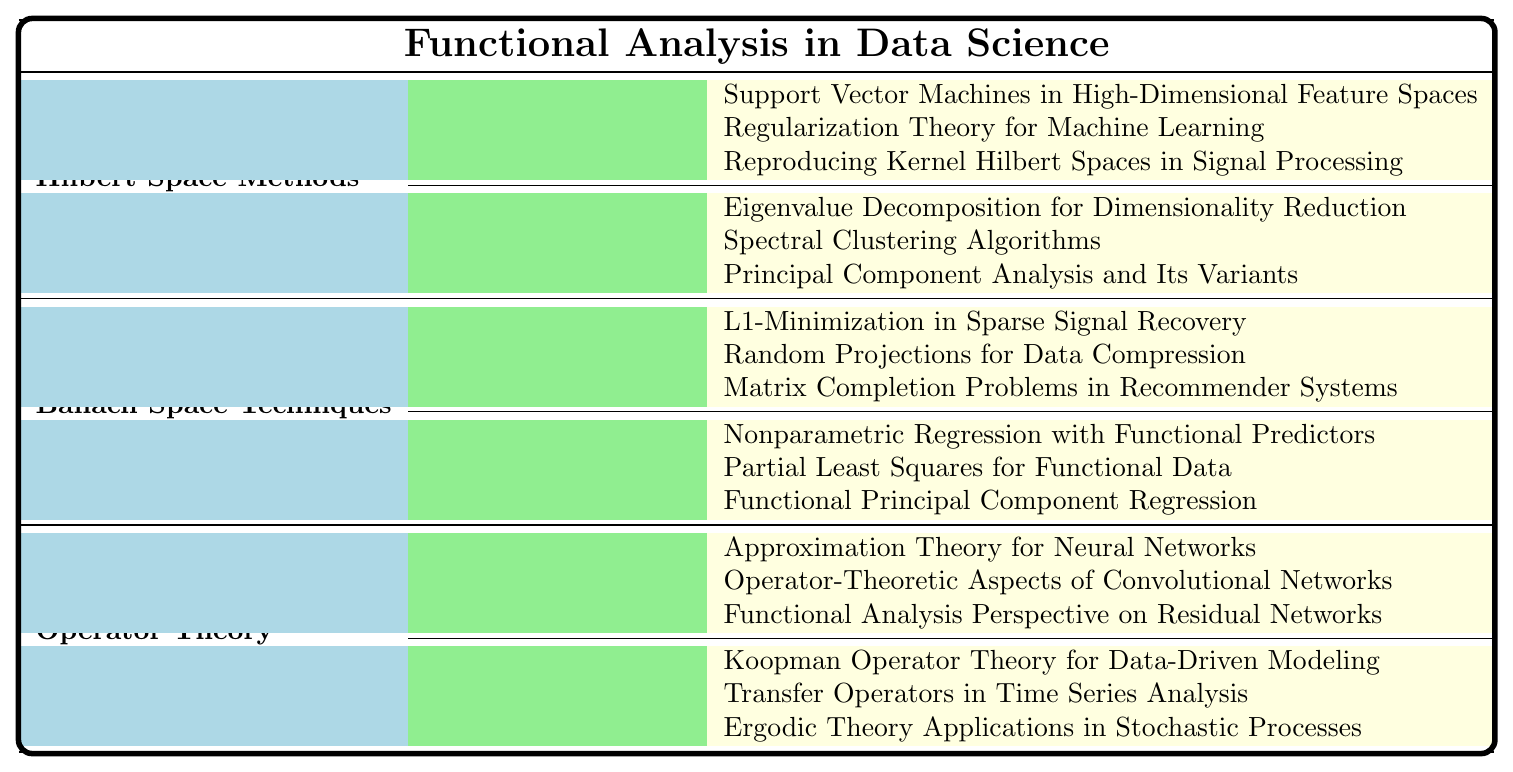What are the main categories of research papers in functional analysis as applied to data science? The main categories listed in the table are Hilbert Space Methods, Banach Space Techniques, and Operator Theory. Each of these categories encompasses various subcategories and specific research papers.
Answer: Hilbert Space Methods, Banach Space Techniques, Operator Theory How many research papers are under Kernel Methods in Hilbert Space Methods? There are three research papers listed under Kernel Methods: "Support Vector Machines in High-Dimensional Feature Spaces", "Regularization Theory for Machine Learning", and "Reproducing Kernel Hilbert Spaces in Signal Processing".
Answer: 3 Is "Functional Principal Component Regression" a paper under Banach Space Techniques or Hilbert Space Methods? "Functional Principal Component Regression" is listed under Functional Regression, which is a subcategory of Banach Space Techniques.
Answer: Banach Space Techniques Which research paper focuses on data compression techniques? The paper that focuses on data compression techniques is "Random Projections for Data Compression" under Compressed Sensing in Banach Space Techniques.
Answer: Random Projections for Data Compression What is the total number of research papers listed in the Operator Theory category? There are six papers listed under Operator Theory: three under Deep Learning and three under Dynamical Systems, totaling to six papers.
Answer: 6 Are there more techniques listed in Hilbert Space Methods or Banach Space Techniques? Both Hilbert Space Methods and Banach Space Techniques have two techniques each; hence, they have the same number of techniques listed.
Answer: Neither, they are equal How many different subcategories are included under the Operator Theory category? Under the Operator Theory category, there are two subcategories: Deep Learning and Dynamical Systems.
Answer: 2 Which category contains research focused on neural networks? The category that contains research focused on neural networks is Operator Theory, specifically under the subcategory Deep Learning.
Answer: Operator Theory If you combine the research topics of Hilbert Space Methods and Banach Space Techniques, how many unique research papers would you have? Hilbert Space Methods has six papers and Banach Space Techniques also has six papers, totaling twelve. All papers are unique with no overlaps between the two categories.
Answer: 12 Is "Transfer Operators in Time Series Analysis" related to the field of deep learning? No, "Transfer Operators in Time Series Analysis" is related to Dynamical Systems within the Operator Theory category, not deep learning.
Answer: No 